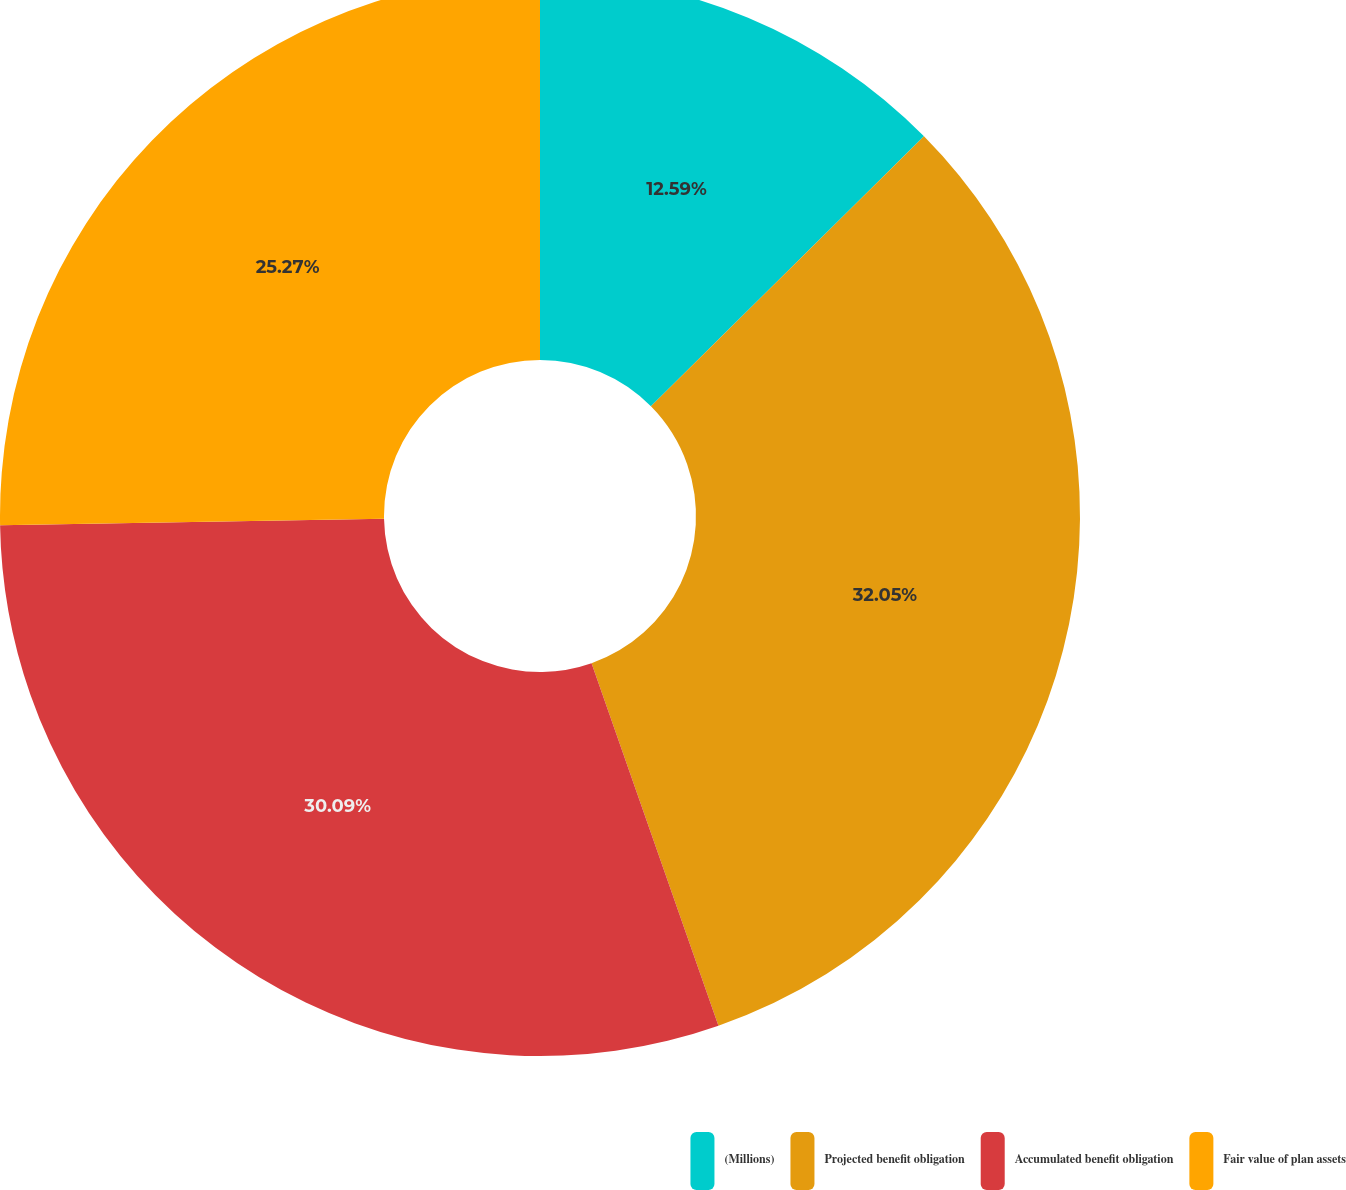Convert chart. <chart><loc_0><loc_0><loc_500><loc_500><pie_chart><fcel>(Millions)<fcel>Projected benefit obligation<fcel>Accumulated benefit obligation<fcel>Fair value of plan assets<nl><fcel>12.59%<fcel>32.05%<fcel>30.09%<fcel>25.27%<nl></chart> 